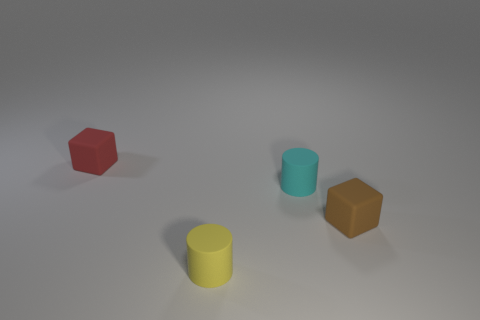Add 2 tiny brown matte spheres. How many objects exist? 6 Subtract 0 blue cylinders. How many objects are left? 4 Subtract all metallic cylinders. Subtract all brown cubes. How many objects are left? 3 Add 4 tiny red cubes. How many tiny red cubes are left? 5 Add 1 small blue rubber objects. How many small blue rubber objects exist? 1 